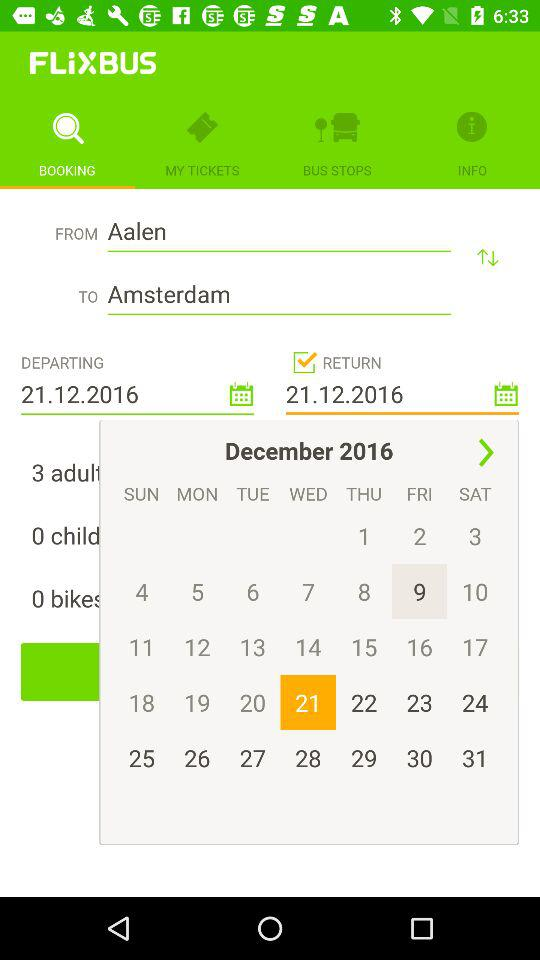What is the return date? The return date is Wednesday, December 21, 2016. 